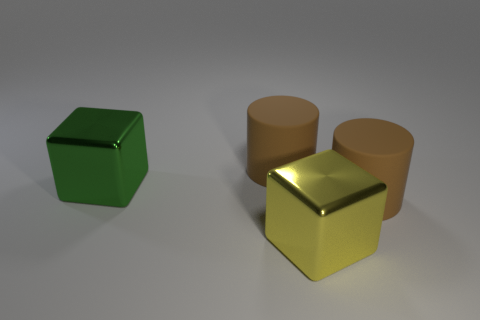Are there fewer big yellow shiny blocks that are on the right side of the yellow metal object than cubes that are behind the large green block?
Your response must be concise. No. How many other large green objects are made of the same material as the large green object?
Offer a terse response. 0. There is a large rubber cylinder that is to the right of the big brown matte cylinder behind the green cube; is there a big green metallic cube that is on the right side of it?
Offer a terse response. No. Is the number of big gray things greater than the number of big brown objects?
Keep it short and to the point. No. There is a big green shiny object; is its shape the same as the object behind the green thing?
Provide a short and direct response. No. What material is the green thing?
Give a very brief answer. Metal. What is the color of the large rubber cylinder that is left of the yellow metal thing that is on the right side of the metal block that is on the left side of the large yellow metal block?
Offer a very short reply. Brown. What is the material of the other large thing that is the same shape as the big green metal thing?
Give a very brief answer. Metal. How many green things have the same size as the yellow metal thing?
Your answer should be very brief. 1. How many red objects are there?
Make the answer very short. 0. 